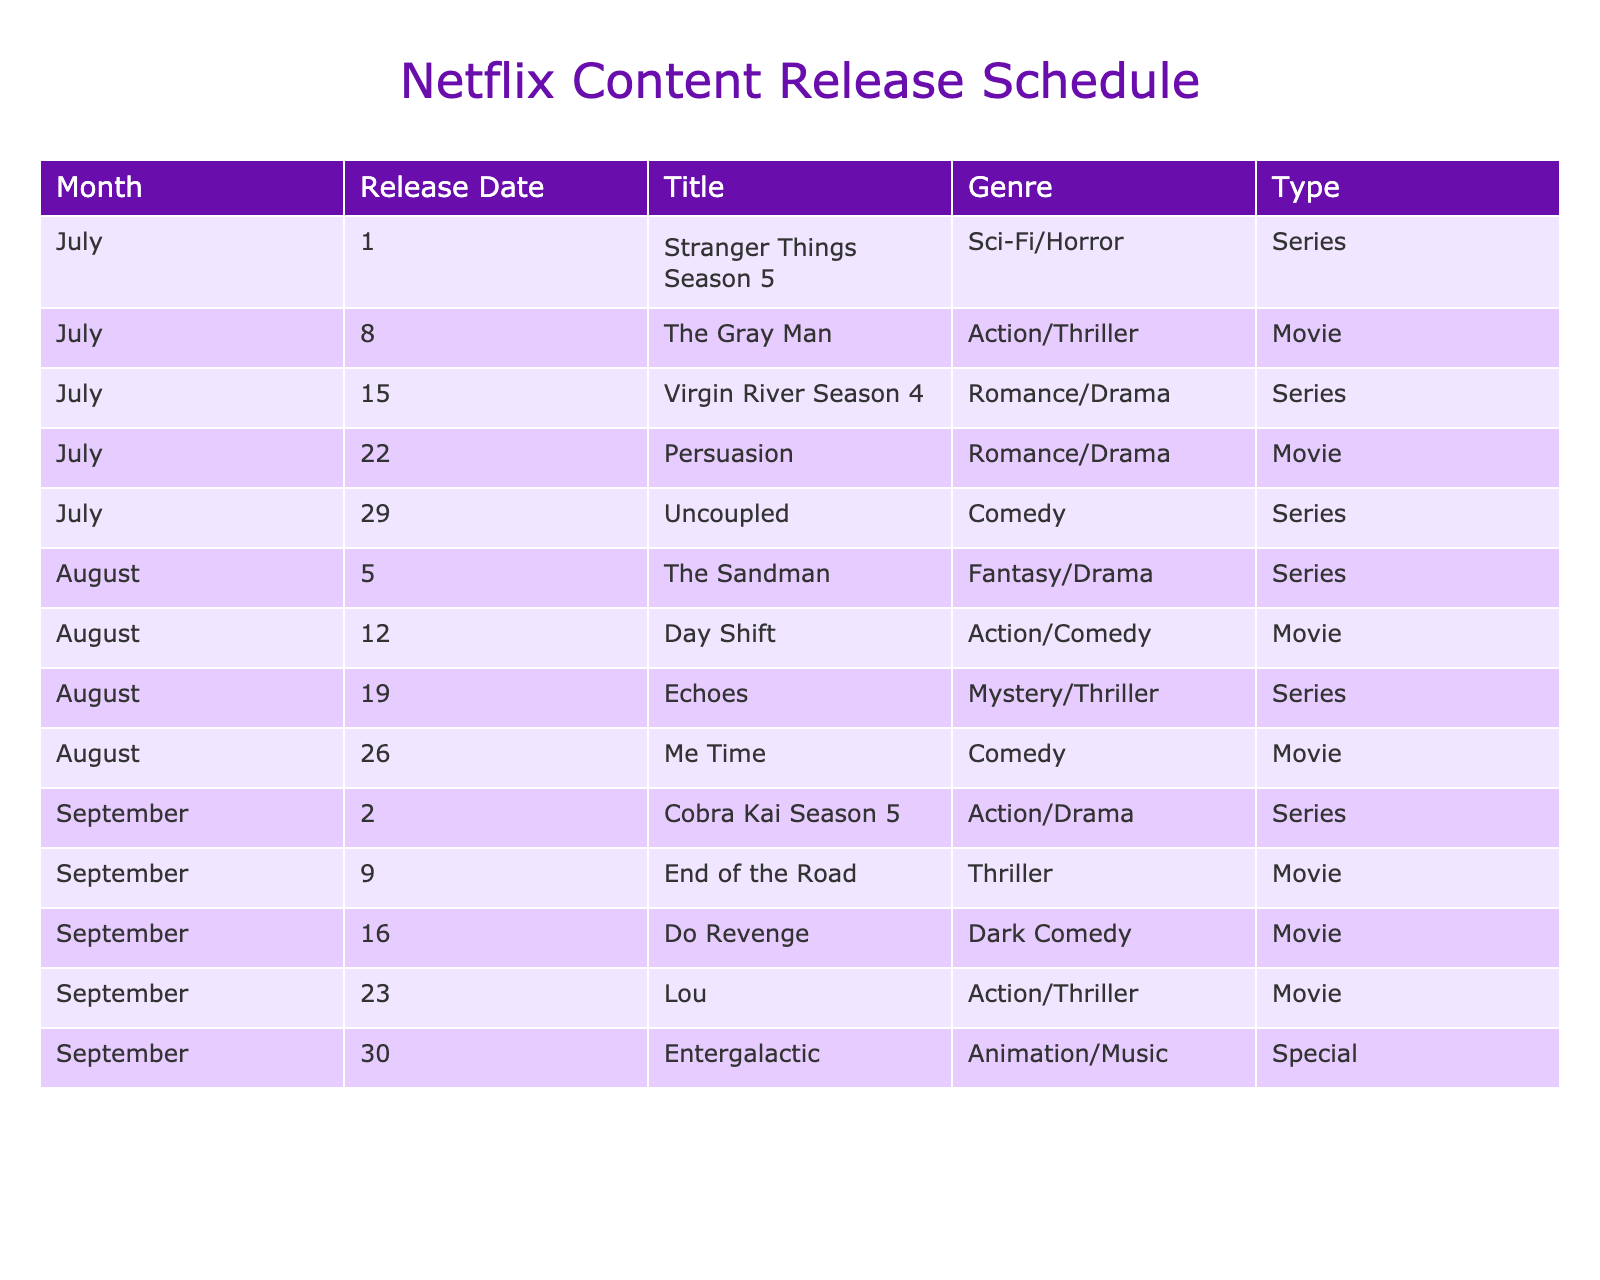What titles are set to be released in July? By scanning the "Month" column, I can see that July has listed four titles: "Stranger Things Season 5," "The Gray Man," "Virgin River Season 4," and "Persuasion."
Answer: Stranger Things Season 5, The Gray Man, Virgin River Season 4, Persuasion How many movies are being released in August? In the "Type" column, I can count the titles listed under August: "Day Shift" and "Me Time" are categorized as movies, giving a total of two movies for that month.
Answer: 2 Which series has the earliest release date in September? Looking at the "Release Date" under September, "Cobra Kai Season 5" is listed first on September 2, making it the earliest series release for that month.
Answer: Cobra Kai Season 5 Are there any comedy movies being released in August? Checking the "Genre" for the titles in August, I see only one movie, "Day Shift," but the genre listed for it is Action/Comedy, indicating that it fits into both categories.
Answer: Yes What is the total number of series being released in the upcoming quarter? I need to count all the entries in the "Type" column that are labeled as "Series." There are a total of six series: "Stranger Things Season 5," "Virgin River Season 4," "Uncoupled," "The Sandman," "Echoes," and "Cobra Kai Season 5."
Answer: 6 Which month has the highest number of movie releases? By comparing the counts of movie titles across all months, July has two ("The Gray Man" and "Persuasion"), August has two ("Day Shift" and "Me Time"), and September has four ("End of the Road," "Do Revenge," "Lou," and "Entergalactic"). Thus, September has the highest number of movies.
Answer: September Is there a title under the Action/Thriller genre being released on July 22? I can look specifically at the date July 22 and see that it lists "Persuasion," which is categorized as a Romance/Drama, not fitting the Action/Thriller genre.
Answer: No What is the genre of "Echoes," and when is it released? "Echoes" is listed in the genre column as Mystery/Thriller, and it has a release date of August 19.
Answer: Mystery/Thriller, August 19 How many titles are released on September 16, and are they movies or series? The table shows one title on September 16: "Do Revenge," and it is categorized as a movie.
Answer: 1 movie What percentage of the total releases in this quarter are series? There are a total of 12 titles (6 series and 6 movies), making the percentage of series releases calculated as (6/12) * 100 = 50%.
Answer: 50% 